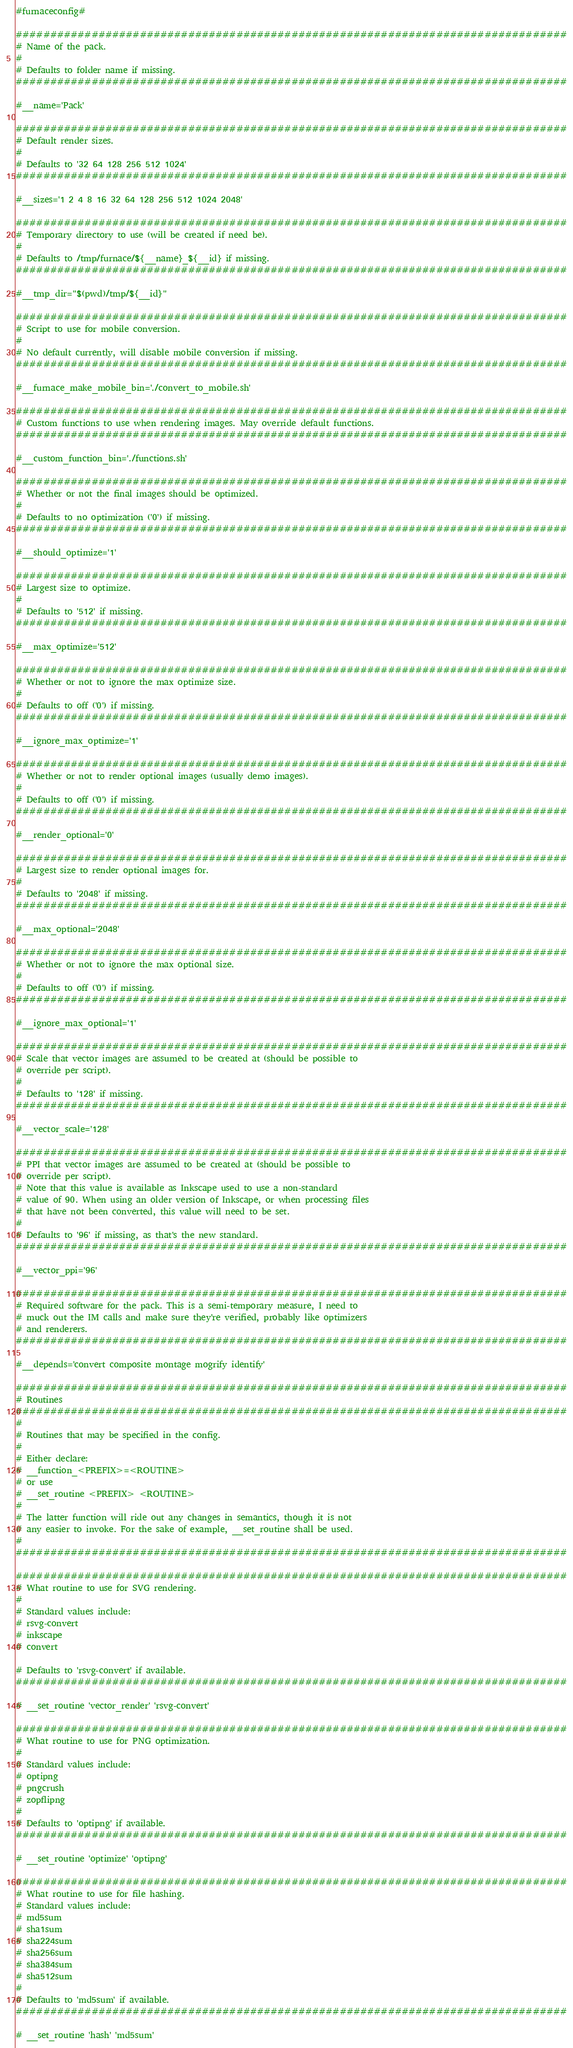<code> <loc_0><loc_0><loc_500><loc_500><_Bash_>#furnaceconfig#

################################################################################
# Name of the pack.
#
# Defaults to folder name if missing.
################################################################################

#__name='Pack'

################################################################################
# Default render sizes.
#
# Defaults to '32 64 128 256 512 1024'
################################################################################

#__sizes='1 2 4 8 16 32 64 128 256 512 1024 2048'

################################################################################
# Temporary directory to use (will be created if need be).
#
# Defaults to /tmp/furnace/${__name}_${__id} if missing.
################################################################################

#__tmp_dir="$(pwd)/tmp/${__id}"

################################################################################
# Script to use for mobile conversion.
#
# No default currently, will disable mobile conversion if missing.
################################################################################

#__furnace_make_mobile_bin='./convert_to_mobile.sh'

################################################################################
# Custom functions to use when rendering images. May override default functions.
################################################################################

#__custom_function_bin='./functions.sh'

################################################################################
# Whether or not the final images should be optimized.
#
# Defaults to no optimization ('0') if missing.
################################################################################

#__should_optimize='1'

################################################################################
# Largest size to optimize.
#
# Defaults to '512' if missing.
################################################################################

#__max_optimize='512'

################################################################################
# Whether or not to ignore the max optimize size.
#
# Defaults to off ('0') if missing.
################################################################################

#__ignore_max_optimize='1'

################################################################################
# Whether or not to render optional images (usually demo images).
#
# Defaults to off ('0') if missing.
################################################################################

#__render_optional='0'

################################################################################
# Largest size to render optional images for.
#
# Defaults to '2048' if missing.
################################################################################

#__max_optional='2048'

################################################################################
# Whether or not to ignore the max optional size.
#
# Defaults to off ('0') if missing.
################################################################################

#__ignore_max_optional='1'

################################################################################
# Scale that vector images are assumed to be created at (should be possible to
# override per script).
#
# Defaults to '128' if missing.
################################################################################

#__vector_scale='128'

################################################################################
# PPI that vector images are assumed to be created at (should be possible to
# override per script).
# Note that this value is available as Inkscape used to use a non-standard
# value of 90. When using an older version of Inkscape, or when processing files
# that have not been converted, this value will need to be set.
#
# Defaults to '96' if missing, as that's the new standard.
################################################################################

#__vector_ppi='96'

################################################################################
# Required software for the pack. This is a semi-temporary measure, I need to
# muck out the IM calls and make sure they're verified, probably like optimizers
# and renderers.
################################################################################

#__depends='convert composite montage mogrify identify'

################################################################################
# Routines
################################################################################
#
# Routines that may be specified in the config.
#
# Either declare:
# __function_<PREFIX>=<ROUTINE>
# or use
# __set_routine <PREFIX> <ROUTINE>
#
# The latter function will ride out any changes in semantics, though it is not
# any easier to invoke. For the sake of example, __set_routine shall be used.
#
################################################################################

################################################################################
# What routine to use for SVG rendering.
#
# Standard values include:
# rsvg-convert
# inkscape
# convert

# Defaults to 'rsvg-convert' if available.
################################################################################

# __set_routine 'vector_render' 'rsvg-convert'

################################################################################
# What routine to use for PNG optimization.
#
# Standard values include:
# optipng
# pngcrush
# zopflipng
#
# Defaults to 'optipng' if available.
################################################################################

# __set_routine 'optimize' 'optipng'

################################################################################
# What routine to use for file hashing.
# Standard values include:
# md5sum
# sha1sum
# sha224sum
# sha256sum
# sha384sum
# sha512sum
#
# Defaults to 'md5sum' if available.
################################################################################

# __set_routine 'hash' 'md5sum'
</code> 